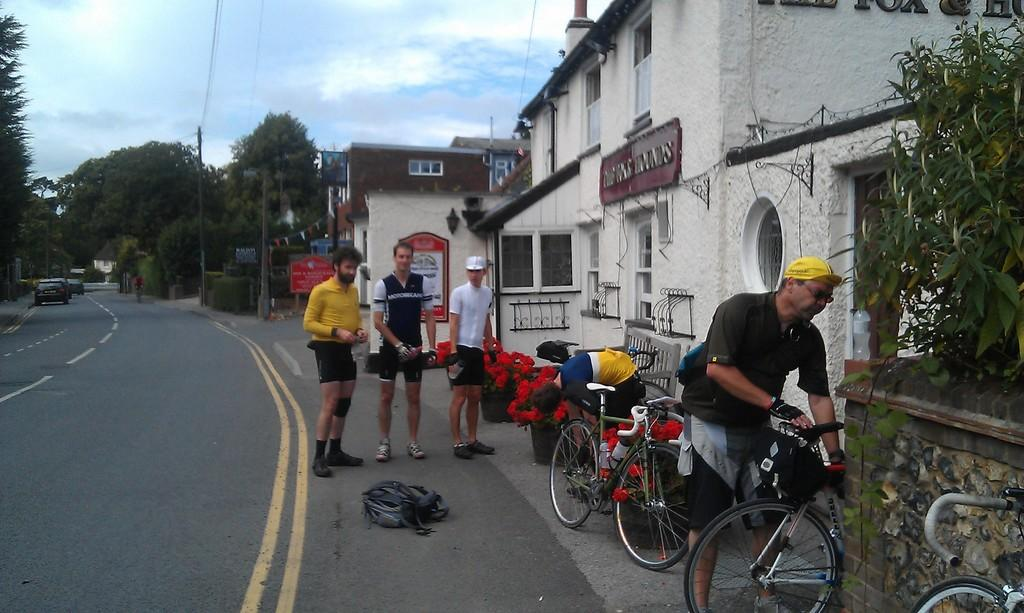What can be seen in the sky in the image? There is a sky in the image, but no specific details about the sky are mentioned. What type of vegetation is present in the image? There are trees in the image. What is the main feature of the landscape in the image? There is a road in the image. What type of vehicles are on the road? There are cars on the road. Where is the building located in the image? There is a building on the right side of the image. What other objects or features are on the right side of the image? There is a bicycle and flowers on the right side of the image. Are there any people visible in the image? Yes, there are people on the road. What flavor of mine is depicted in the image? There is no mine or mention of flavor in the image. How does the fog affect the visibility of the people on the road? There is no fog present in the image; it only mentions a sky, trees, a road, cars, a building, a bicycle, flowers, and people. 